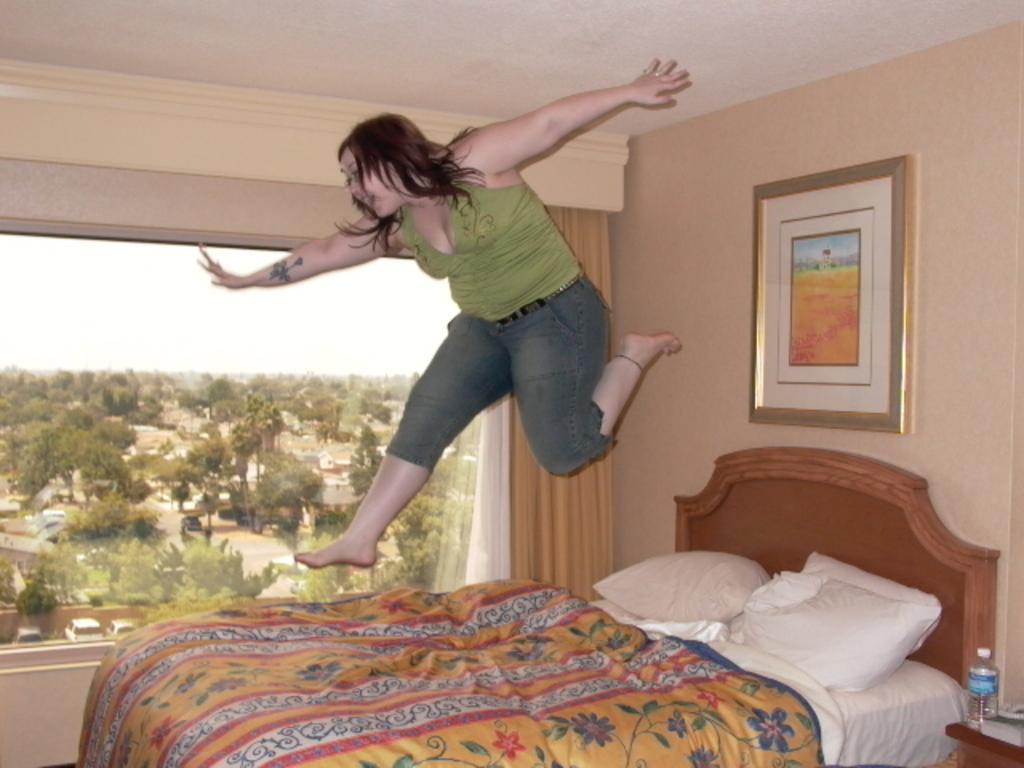Can you describe this image briefly? In this image i can see a woman, a bed and few pillows on the bed. In the background i can see a wall, a photo frame, a curtain and a window through which i can see few trees, few buildings and the sky. 